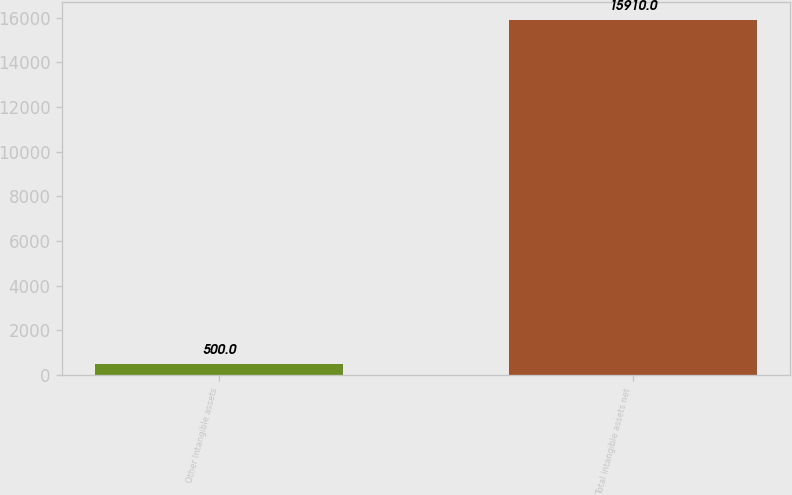Convert chart. <chart><loc_0><loc_0><loc_500><loc_500><bar_chart><fcel>Other Intangible assets<fcel>Total intangible assets net<nl><fcel>500<fcel>15910<nl></chart> 